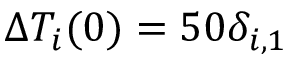<formula> <loc_0><loc_0><loc_500><loc_500>\Delta T _ { i } ( 0 ) = 5 0 \delta _ { i , 1 }</formula> 